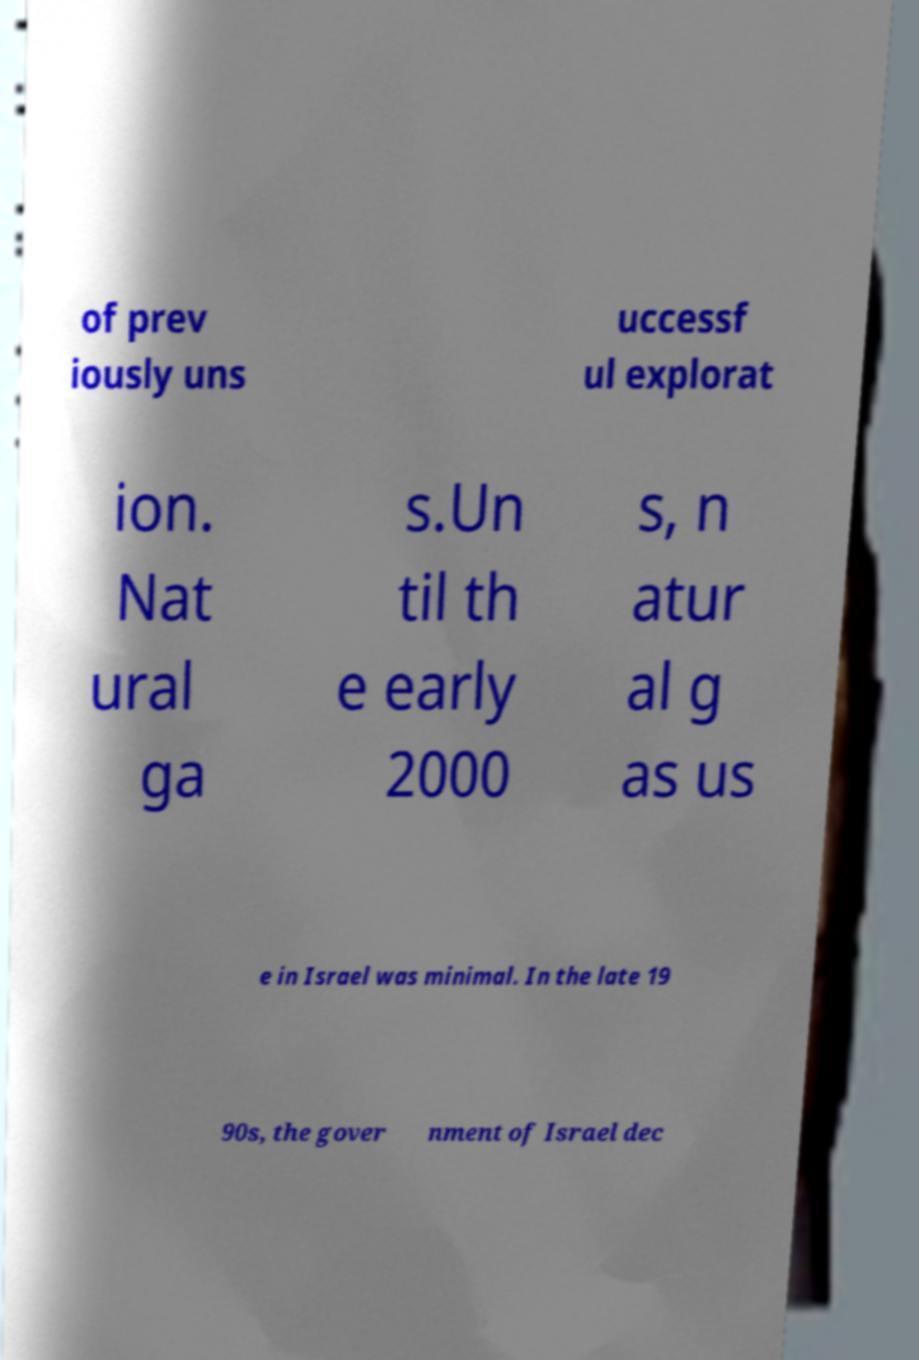I need the written content from this picture converted into text. Can you do that? of prev iously uns uccessf ul explorat ion. Nat ural ga s.Un til th e early 2000 s, n atur al g as us e in Israel was minimal. In the late 19 90s, the gover nment of Israel dec 